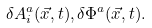Convert formula to latex. <formula><loc_0><loc_0><loc_500><loc_500>\delta A _ { i } ^ { a } ( \vec { x } , t ) , \delta \Phi ^ { a } ( \vec { x } , t ) .</formula> 